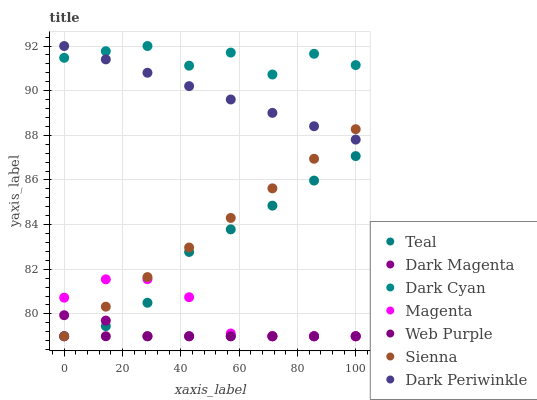Does Web Purple have the minimum area under the curve?
Answer yes or no. Yes. Does Dark Cyan have the maximum area under the curve?
Answer yes or no. Yes. Does Sienna have the minimum area under the curve?
Answer yes or no. No. Does Sienna have the maximum area under the curve?
Answer yes or no. No. Is Web Purple the smoothest?
Answer yes or no. Yes. Is Dark Cyan the roughest?
Answer yes or no. Yes. Is Sienna the smoothest?
Answer yes or no. No. Is Sienna the roughest?
Answer yes or no. No. Does Dark Magenta have the lowest value?
Answer yes or no. Yes. Does Dark Cyan have the lowest value?
Answer yes or no. No. Does Dark Periwinkle have the highest value?
Answer yes or no. Yes. Does Sienna have the highest value?
Answer yes or no. No. Is Web Purple less than Dark Periwinkle?
Answer yes or no. Yes. Is Dark Cyan greater than Teal?
Answer yes or no. Yes. Does Teal intersect Magenta?
Answer yes or no. Yes. Is Teal less than Magenta?
Answer yes or no. No. Is Teal greater than Magenta?
Answer yes or no. No. Does Web Purple intersect Dark Periwinkle?
Answer yes or no. No. 